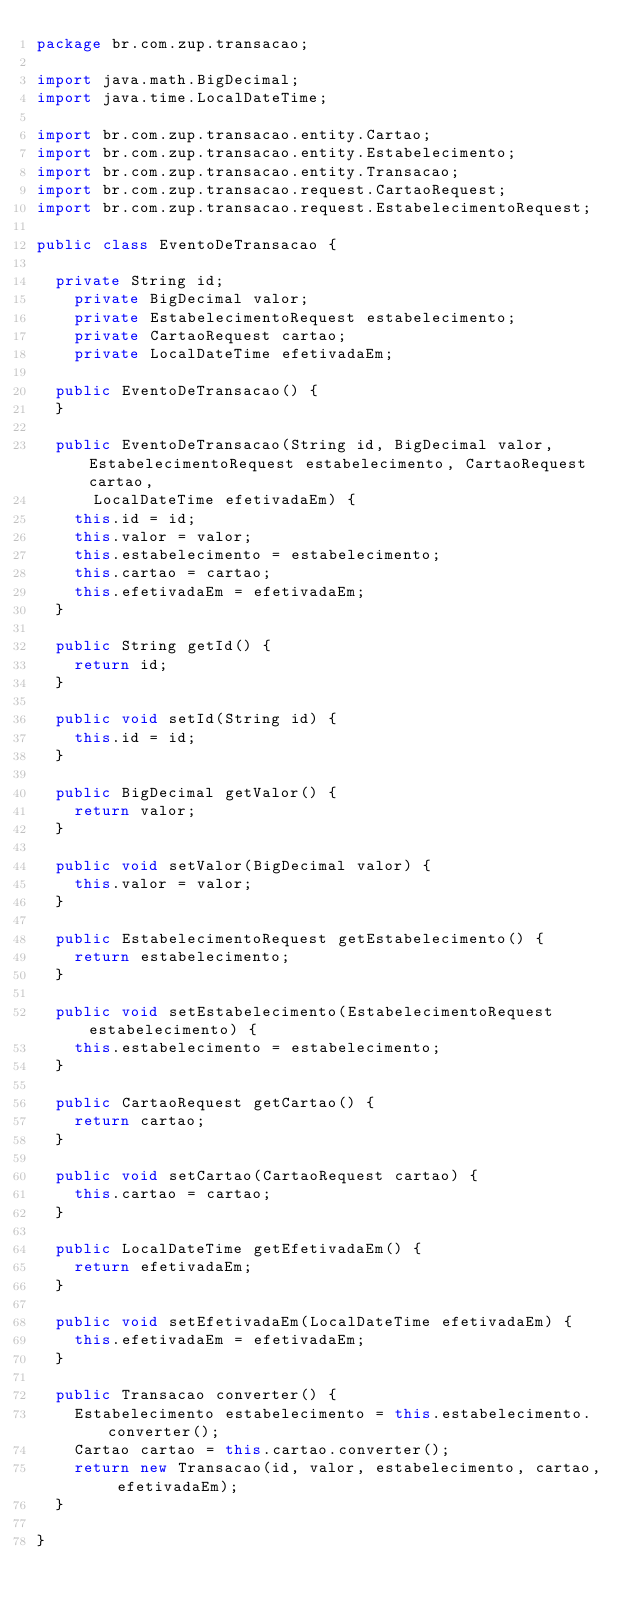<code> <loc_0><loc_0><loc_500><loc_500><_Java_>package br.com.zup.transacao;

import java.math.BigDecimal;
import java.time.LocalDateTime;

import br.com.zup.transacao.entity.Cartao;
import br.com.zup.transacao.entity.Estabelecimento;
import br.com.zup.transacao.entity.Transacao;
import br.com.zup.transacao.request.CartaoRequest;
import br.com.zup.transacao.request.EstabelecimentoRequest;

public class EventoDeTransacao {

	private String id;
    private BigDecimal valor;
    private EstabelecimentoRequest estabelecimento;
    private CartaoRequest cartao;
    private LocalDateTime efetivadaEm;
    
	public EventoDeTransacao() {
	}

	public EventoDeTransacao(String id, BigDecimal valor, EstabelecimentoRequest estabelecimento, CartaoRequest cartao,
			LocalDateTime efetivadaEm) {
		this.id = id;
		this.valor = valor;
		this.estabelecimento = estabelecimento;
		this.cartao = cartao;
		this.efetivadaEm = efetivadaEm;
	}

	public String getId() {
		return id;
	}

	public void setId(String id) {
		this.id = id;
	}

	public BigDecimal getValor() {
		return valor;
	}

	public void setValor(BigDecimal valor) {
		this.valor = valor;
	}

	public EstabelecimentoRequest getEstabelecimento() {
		return estabelecimento;
	}

	public void setEstabelecimento(EstabelecimentoRequest estabelecimento) {
		this.estabelecimento = estabelecimento;
	}

	public CartaoRequest getCartao() {
		return cartao;
	}

	public void setCartao(CartaoRequest cartao) {
		this.cartao = cartao;
	}

	public LocalDateTime getEfetivadaEm() {
		return efetivadaEm;
	}

	public void setEfetivadaEm(LocalDateTime efetivadaEm) {
		this.efetivadaEm = efetivadaEm;
	}

	public Transacao converter() {
		Estabelecimento estabelecimento = this.estabelecimento.converter();
		Cartao cartao = this.cartao.converter(); 
		return new Transacao(id, valor, estabelecimento, cartao, efetivadaEm);
	}  
    
}
</code> 